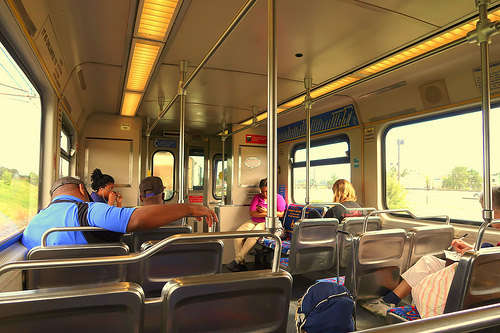<image>
Can you confirm if the woman is in front of the train? No. The woman is not in front of the train. The spatial positioning shows a different relationship between these objects. 